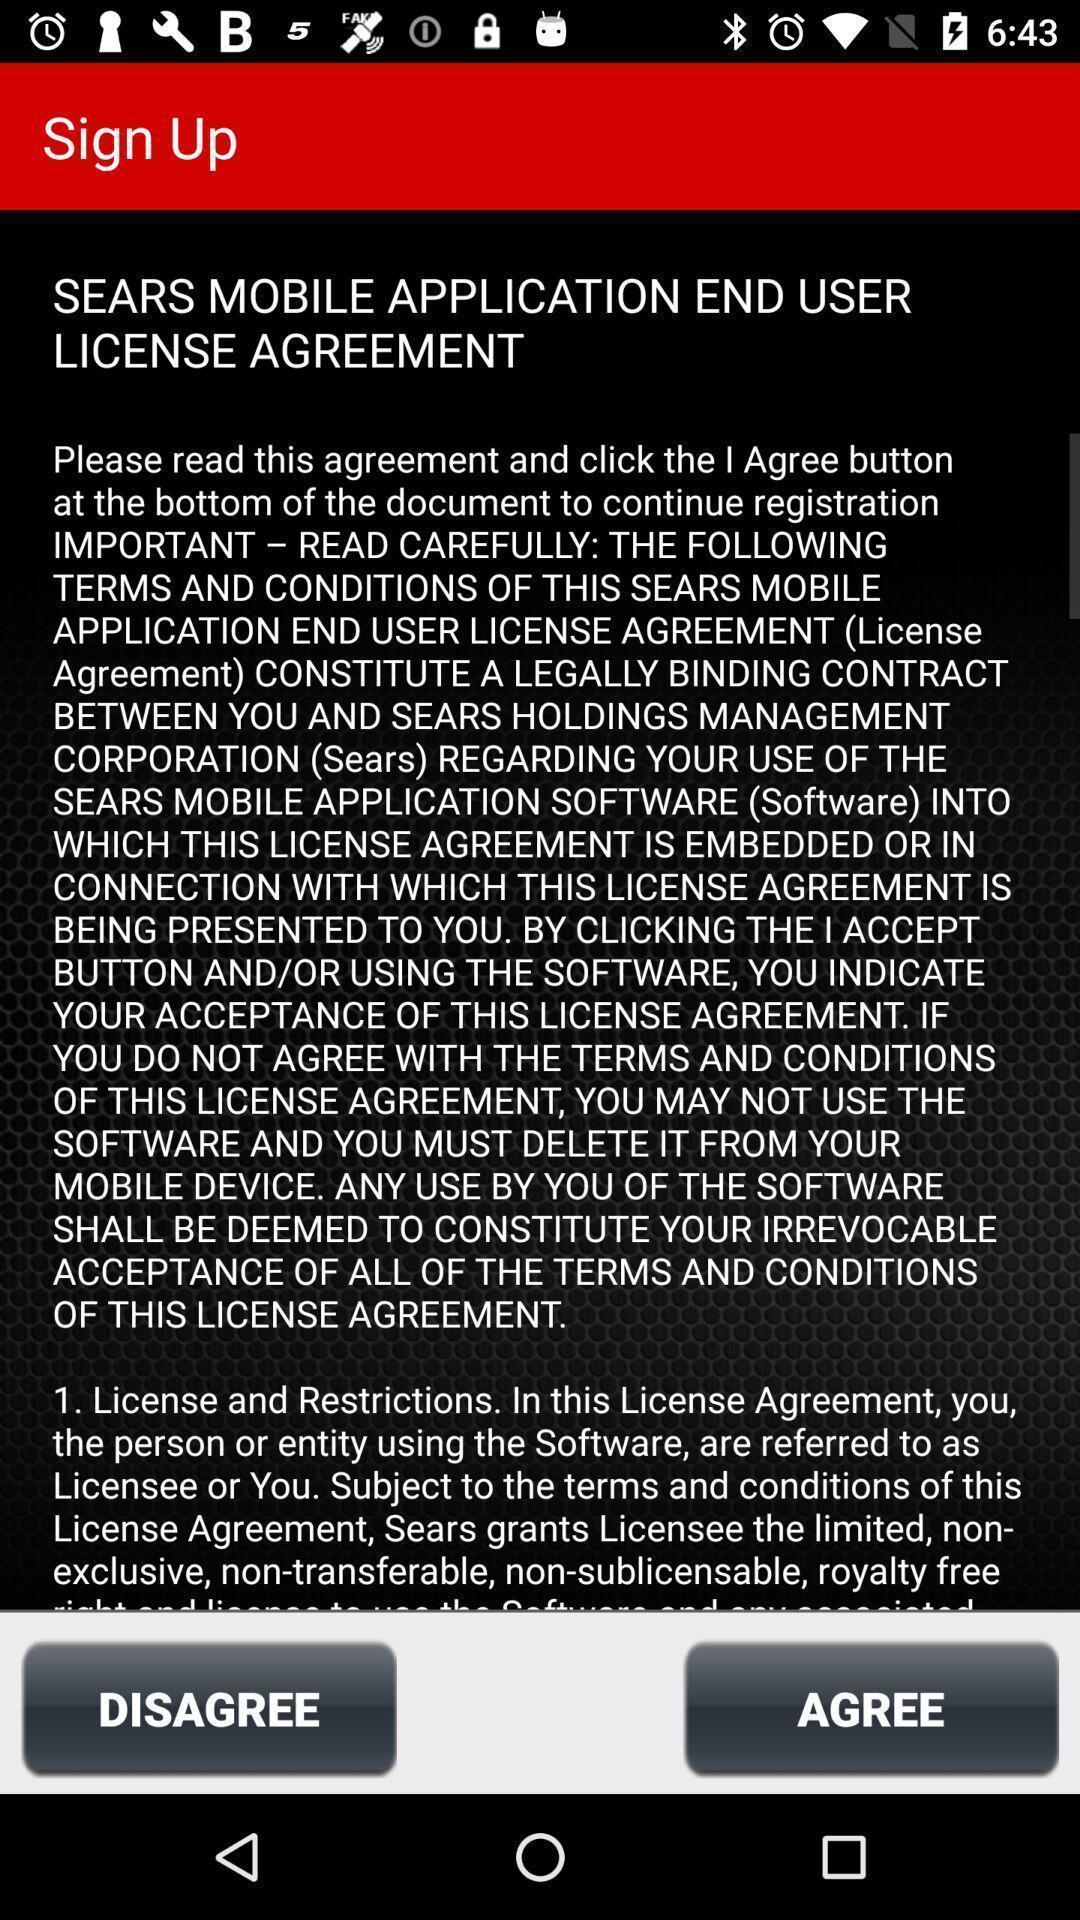Provide a textual representation of this image. Sign up page with privacy policy. 